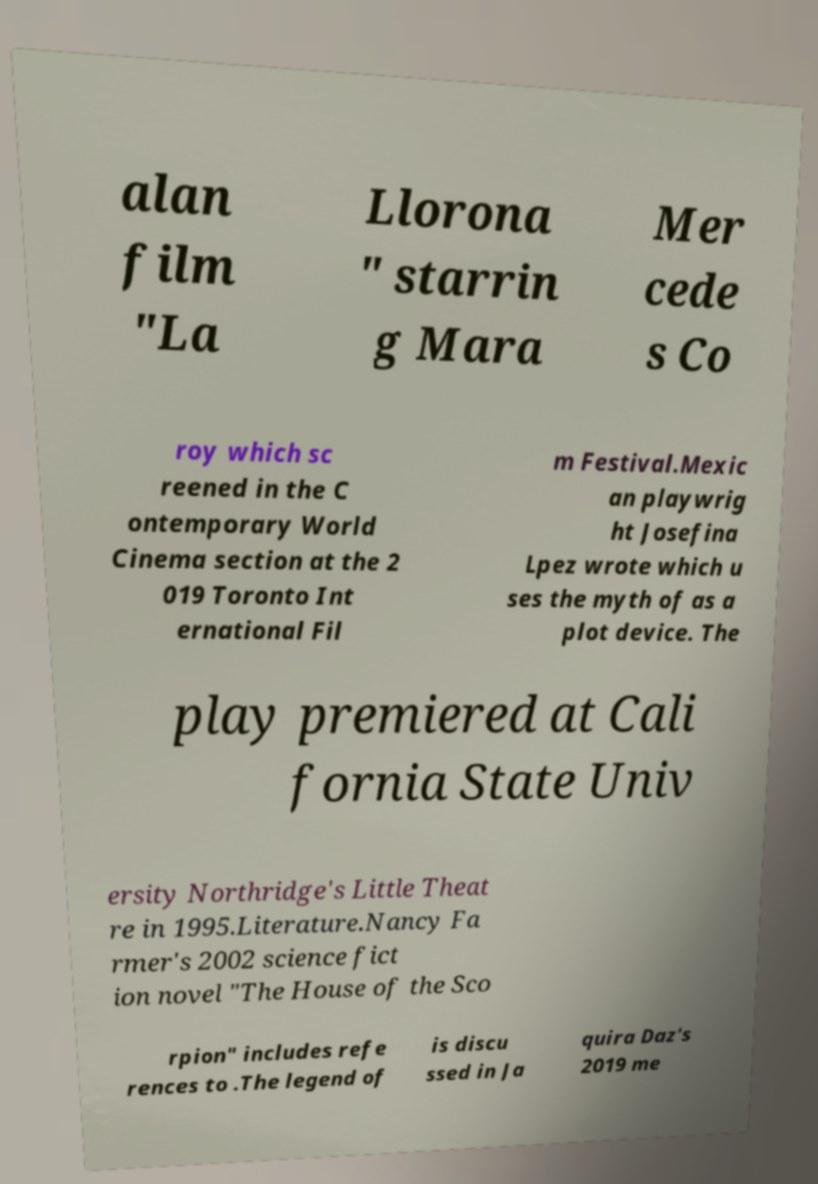What messages or text are displayed in this image? I need them in a readable, typed format. alan film "La Llorona " starrin g Mara Mer cede s Co roy which sc reened in the C ontemporary World Cinema section at the 2 019 Toronto Int ernational Fil m Festival.Mexic an playwrig ht Josefina Lpez wrote which u ses the myth of as a plot device. The play premiered at Cali fornia State Univ ersity Northridge's Little Theat re in 1995.Literature.Nancy Fa rmer's 2002 science fict ion novel "The House of the Sco rpion" includes refe rences to .The legend of is discu ssed in Ja quira Daz's 2019 me 